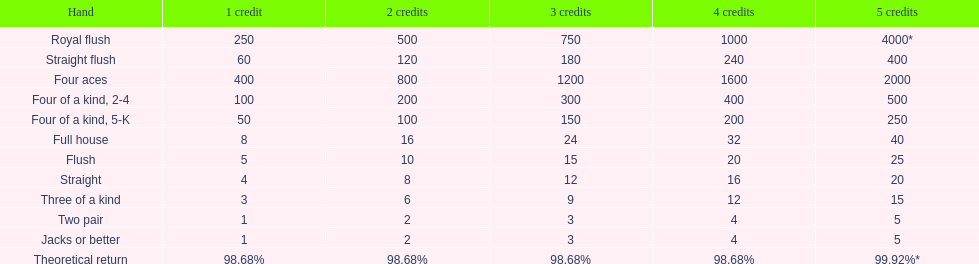The number of credits returned for a one credit bet on a royal flush are. 250. 